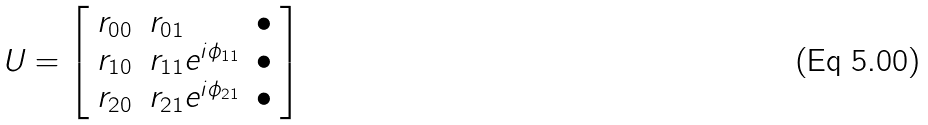Convert formula to latex. <formula><loc_0><loc_0><loc_500><loc_500>U = \left [ \begin{array} { l l l } r _ { 0 0 } & r _ { 0 1 } & \bullet \\ r _ { 1 0 } & r _ { 1 1 } e ^ { i { \phi } _ { 1 1 } } & \bullet \\ r _ { 2 0 } & r _ { 2 1 } e ^ { i { \phi } _ { 2 1 } } & \bullet \end{array} \right ]</formula> 